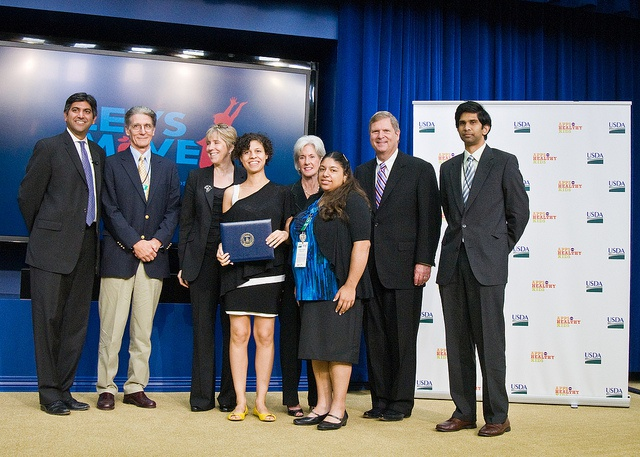Describe the objects in this image and their specific colors. I can see people in blue, black, and gray tones, people in blue, black, navy, and gray tones, people in blue, black, and tan tones, people in blue, black, lightpink, brown, and lightgray tones, and people in blue, black, tan, and navy tones in this image. 